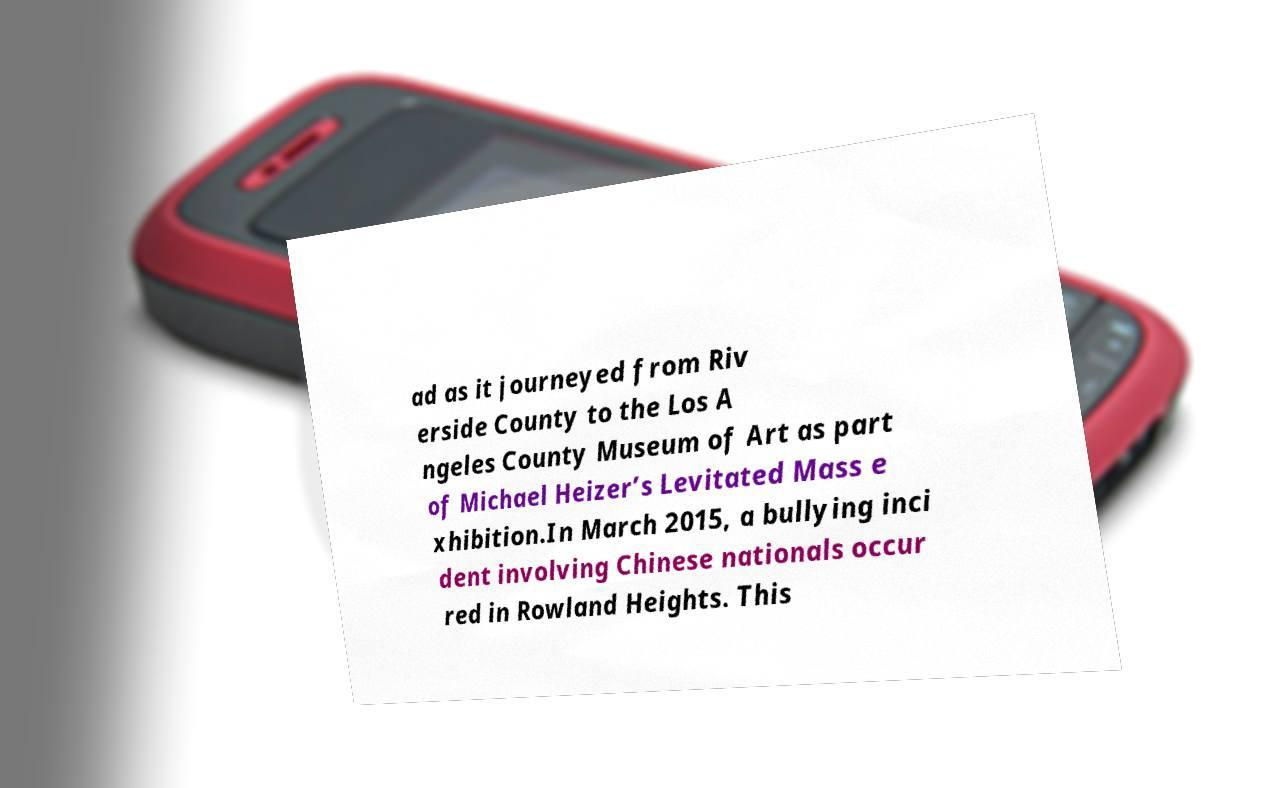What messages or text are displayed in this image? I need them in a readable, typed format. ad as it journeyed from Riv erside County to the Los A ngeles County Museum of Art as part of Michael Heizer’s Levitated Mass e xhibition.In March 2015, a bullying inci dent involving Chinese nationals occur red in Rowland Heights. This 